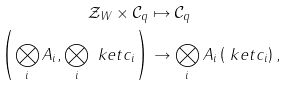Convert formula to latex. <formula><loc_0><loc_0><loc_500><loc_500>\mathcal { Z } _ { W } \times \mathcal { C } _ { q } & \mapsto \mathcal { C } _ { q } \\ \left ( \bigotimes _ { i } A _ { i } , \bigotimes _ { i } \ k e t { c _ { i } } \right ) & \rightarrow \bigotimes _ { i } A _ { i } \left ( \ k e t { c _ { i } } \right ) ,</formula> 